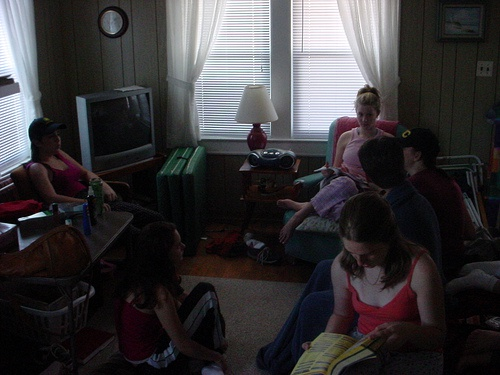Describe the objects in this image and their specific colors. I can see people in lightgray, black, maroon, and gray tones, people in lightgray, black, darkblue, and purple tones, tv in lightgray, black, gray, and blue tones, couch in lavender, black, and purple tones, and people in lightgray, black, maroon, and gray tones in this image. 